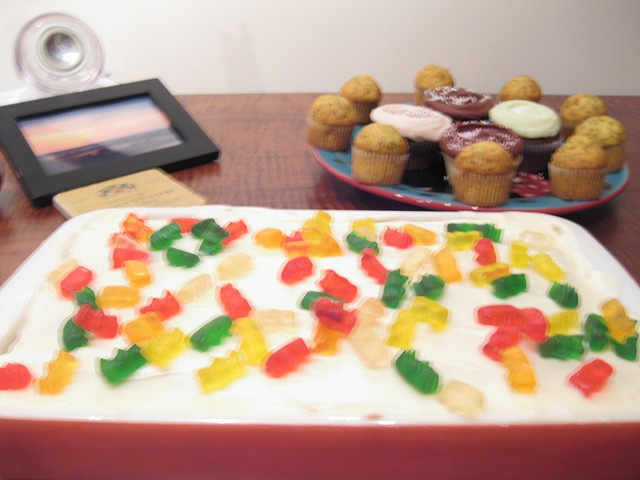Describe the objects in this image and their specific colors. I can see dining table in lightgray, ivory, tan, brown, and gray tones and cake in lightgray, ivory, tan, brown, and salmon tones in this image. 